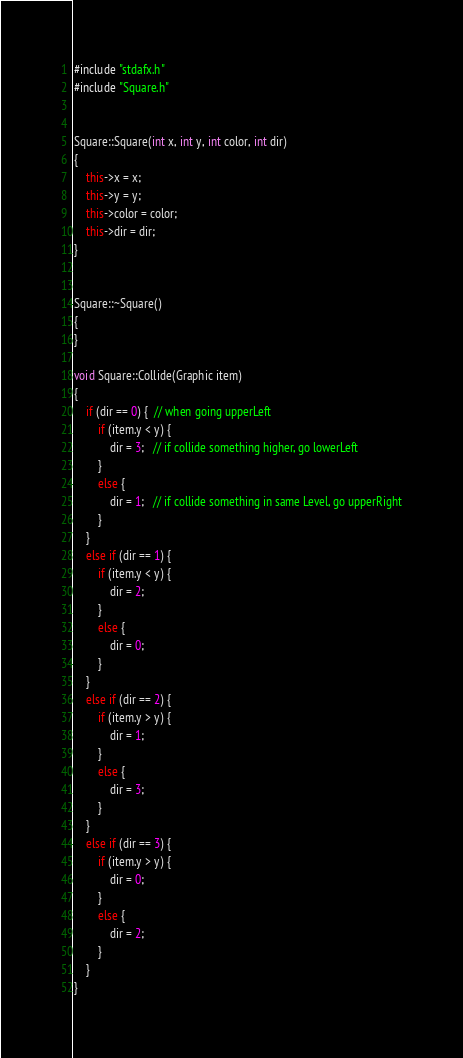<code> <loc_0><loc_0><loc_500><loc_500><_C++_>#include "stdafx.h"
#include "Square.h"


Square::Square(int x, int y, int color, int dir)
{
	this->x = x;
	this->y = y;
	this->color = color;
	this->dir = dir;
}


Square::~Square()
{
}

void Square::Collide(Graphic item)
{
	if (dir == 0) {  // when going upperLeft
		if (item.y < y) {
			dir = 3;   // if collide something higher, go lowerLeft
		}
		else {
			dir = 1;   // if collide something in same Level, go upperRight
		}
	}
	else if (dir == 1) {
		if (item.y < y) {
			dir = 2;
		}
		else {
			dir = 0;
		}
	}
	else if (dir == 2) {
		if (item.y > y) {
			dir = 1;
		}
		else {
			dir = 3;
		}
	}
	else if (dir == 3) {
		if (item.y > y) {
			dir = 0;
		}
		else {
			dir = 2;
		}
	}
}

</code> 